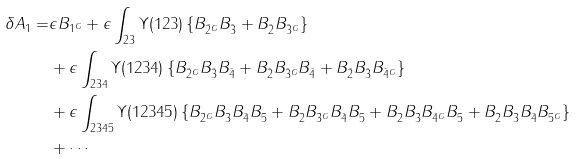<formula> <loc_0><loc_0><loc_500><loc_500>\delta A _ { 1 } = & \epsilon B _ { 1 ^ { G } } + \epsilon \int _ { 2 3 } \Upsilon ( 1 2 3 ) \left \{ B _ { \bar { 2 } ^ { G } } B _ { \bar { 3 } } + B _ { \bar { 2 } } B _ { \bar { 3 } ^ { G } } \right \} \\ & + \epsilon \int _ { 2 3 4 } \Upsilon ( 1 2 3 4 ) \left \{ B _ { \bar { 2 } ^ { G } } B _ { \bar { 3 } } B _ { \bar { 4 } } + B _ { \bar { 2 } } B _ { \bar { 3 } ^ { G } } B _ { \bar { 4 } } + B _ { \bar { 2 } } B _ { \bar { 3 } } B _ { \bar { 4 } ^ { G } } \right \} \\ & + \epsilon \int _ { 2 3 4 5 } \Upsilon ( 1 2 3 4 5 ) \left \{ B _ { \bar { 2 } ^ { G } } B _ { \bar { 3 } } B _ { \bar { 4 } } B _ { \bar { 5 } } + B _ { \bar { 2 } } B _ { \bar { 3 } ^ { G } } B _ { \bar { 4 } } B _ { \bar { 5 } } + B _ { \bar { 2 } } B _ { \bar { 3 } } B _ { \bar { 4 } ^ { G } } B _ { \bar { 5 } } + B _ { \bar { 2 } } B _ { \bar { 3 } } B _ { \bar { 4 } } B _ { \bar { 5 } ^ { G } } \right \} \\ & + \cdots</formula> 